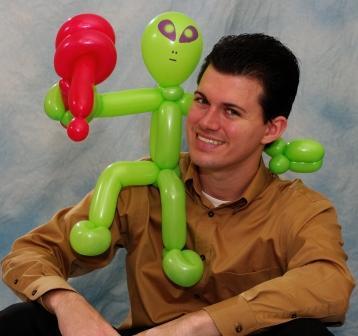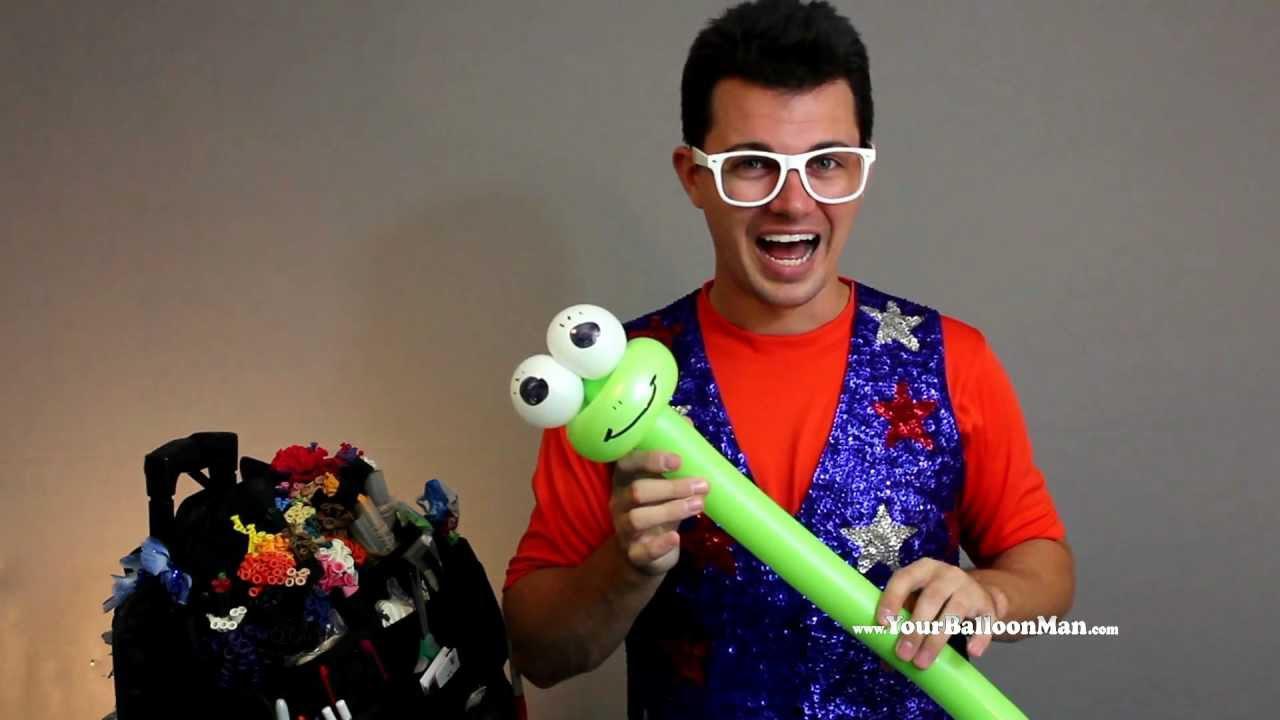The first image is the image on the left, the second image is the image on the right. Given the left and right images, does the statement "In at least one image there are at least six pink ballons making a skirt." hold true? Answer yes or no. No. The first image is the image on the left, the second image is the image on the right. Evaluate the accuracy of this statement regarding the images: "The right and left images contain human figures made out of balloons, and one image includes a blond balloon woman wearing a pink skirt.". Is it true? Answer yes or no. No. 